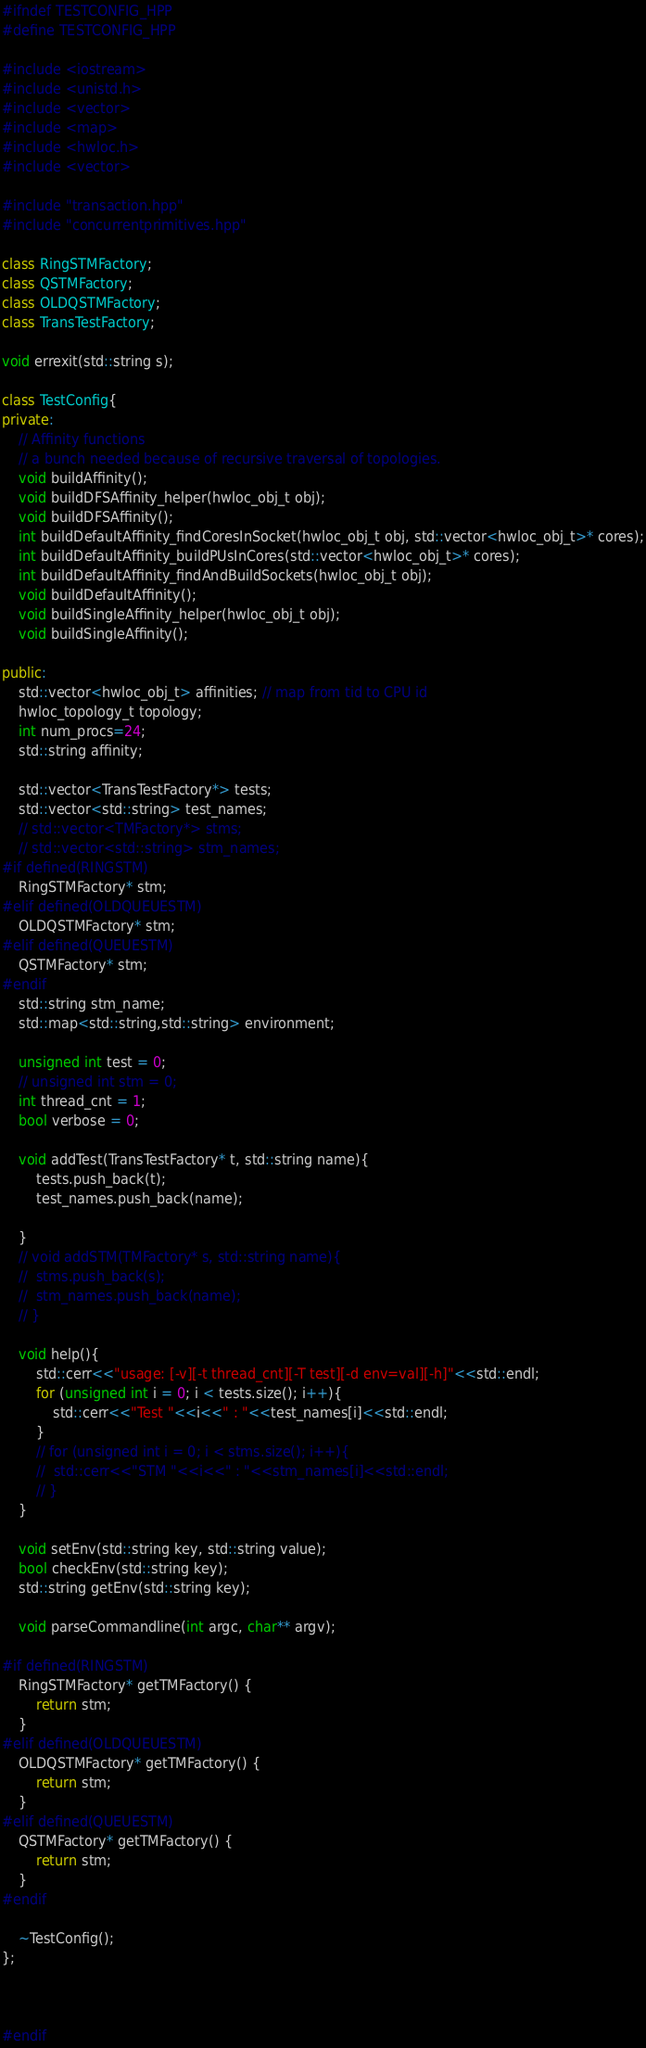Convert code to text. <code><loc_0><loc_0><loc_500><loc_500><_C++_>#ifndef TESTCONFIG_HPP
#define TESTCONFIG_HPP

#include <iostream>
#include <unistd.h>
#include <vector>
#include <map>
#include <hwloc.h>
#include <vector>

#include "transaction.hpp"
#include "concurrentprimitives.hpp"

class RingSTMFactory;
class QSTMFactory;
class OLDQSTMFactory;
class TransTestFactory;

void errexit(std::string s);

class TestConfig{
private:
	// Affinity functions
	// a bunch needed because of recursive traversal of topologies.
	void buildAffinity();
	void buildDFSAffinity_helper(hwloc_obj_t obj);
	void buildDFSAffinity();
	int buildDefaultAffinity_findCoresInSocket(hwloc_obj_t obj, std::vector<hwloc_obj_t>* cores);
	int buildDefaultAffinity_buildPUsInCores(std::vector<hwloc_obj_t>* cores);
	int buildDefaultAffinity_findAndBuildSockets(hwloc_obj_t obj);
	void buildDefaultAffinity();
	void buildSingleAffinity_helper(hwloc_obj_t obj);
	void buildSingleAffinity();

public:
	std::vector<hwloc_obj_t> affinities; // map from tid to CPU id
	hwloc_topology_t topology;
	int num_procs=24;
	std::string affinity;

	std::vector<TransTestFactory*> tests;
	std::vector<std::string> test_names;
	// std::vector<TMFactory*> stms;
	// std::vector<std::string> stm_names;
#if defined(RINGSTM)
	RingSTMFactory* stm;
#elif defined(OLDQUEUESTM)
	OLDQSTMFactory* stm;
#elif defined(QUEUESTM)
	QSTMFactory* stm;
#endif
	std::string stm_name;
	std::map<std::string,std::string> environment;

	unsigned int test = 0;
	// unsigned int stm = 0;
	int thread_cnt = 1;
	bool verbose = 0;

	void addTest(TransTestFactory* t, std::string name){
		tests.push_back(t);
		test_names.push_back(name);

	}
	// void addSTM(TMFactory* s, std::string name){
	// 	stms.push_back(s);
	// 	stm_names.push_back(name);
	// }

	void help(){
		std::cerr<<"usage: [-v][-t thread_cnt][-T test][-d env=val][-h]"<<std::endl;
		for (unsigned int i = 0; i < tests.size(); i++){
			std::cerr<<"Test "<<i<<" : "<<test_names[i]<<std::endl;
		}
		// for (unsigned int i = 0; i < stms.size(); i++){
		// 	std::cerr<<"STM "<<i<<" : "<<stm_names[i]<<std::endl;
		// }
	}

	void setEnv(std::string key, std::string value);
	bool checkEnv(std::string key);
	std::string getEnv(std::string key);

	void parseCommandline(int argc, char** argv);

#if defined(RINGSTM)
	RingSTMFactory* getTMFactory() {
		return stm;
	}
#elif defined(OLDQUEUESTM)
	OLDQSTMFactory* getTMFactory() {
		return stm;
	}
#elif defined(QUEUESTM)
	QSTMFactory* getTMFactory() {
		return stm;
	}
#endif

	~TestConfig();
};



#endif
</code> 